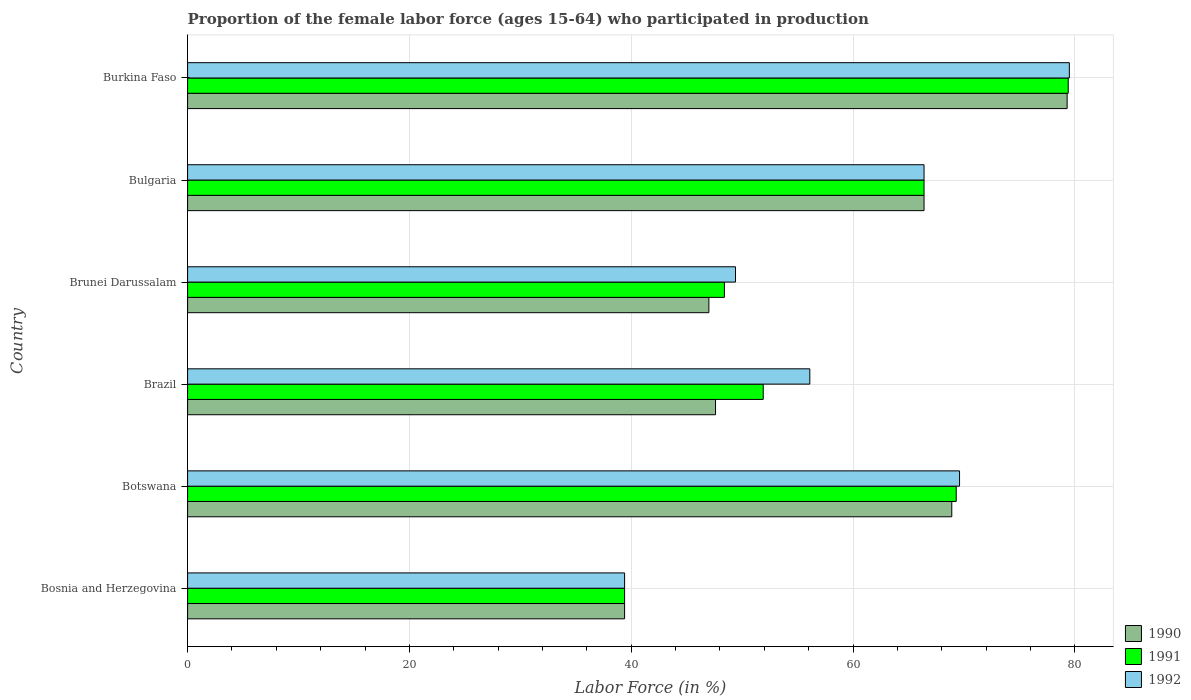How many different coloured bars are there?
Give a very brief answer. 3. How many groups of bars are there?
Keep it short and to the point. 6. Are the number of bars per tick equal to the number of legend labels?
Ensure brevity in your answer.  Yes. How many bars are there on the 2nd tick from the top?
Provide a short and direct response. 3. What is the label of the 4th group of bars from the top?
Give a very brief answer. Brazil. What is the proportion of the female labor force who participated in production in 1992 in Burkina Faso?
Offer a terse response. 79.5. Across all countries, what is the maximum proportion of the female labor force who participated in production in 1990?
Give a very brief answer. 79.3. Across all countries, what is the minimum proportion of the female labor force who participated in production in 1992?
Offer a terse response. 39.4. In which country was the proportion of the female labor force who participated in production in 1991 maximum?
Offer a very short reply. Burkina Faso. In which country was the proportion of the female labor force who participated in production in 1991 minimum?
Provide a short and direct response. Bosnia and Herzegovina. What is the total proportion of the female labor force who participated in production in 1990 in the graph?
Provide a short and direct response. 348.6. What is the difference between the proportion of the female labor force who participated in production in 1992 in Bulgaria and that in Burkina Faso?
Ensure brevity in your answer.  -13.1. What is the difference between the proportion of the female labor force who participated in production in 1990 in Brazil and the proportion of the female labor force who participated in production in 1992 in Bulgaria?
Provide a short and direct response. -18.8. What is the average proportion of the female labor force who participated in production in 1991 per country?
Make the answer very short. 59.13. What is the difference between the proportion of the female labor force who participated in production in 1990 and proportion of the female labor force who participated in production in 1991 in Burkina Faso?
Your response must be concise. -0.1. What is the ratio of the proportion of the female labor force who participated in production in 1990 in Botswana to that in Brunei Darussalam?
Provide a succinct answer. 1.47. Is the difference between the proportion of the female labor force who participated in production in 1990 in Bosnia and Herzegovina and Bulgaria greater than the difference between the proportion of the female labor force who participated in production in 1991 in Bosnia and Herzegovina and Bulgaria?
Provide a succinct answer. No. What is the difference between the highest and the second highest proportion of the female labor force who participated in production in 1990?
Give a very brief answer. 10.4. What is the difference between the highest and the lowest proportion of the female labor force who participated in production in 1991?
Provide a short and direct response. 40. Is the sum of the proportion of the female labor force who participated in production in 1992 in Bosnia and Herzegovina and Burkina Faso greater than the maximum proportion of the female labor force who participated in production in 1990 across all countries?
Your response must be concise. Yes. Is it the case that in every country, the sum of the proportion of the female labor force who participated in production in 1990 and proportion of the female labor force who participated in production in 1992 is greater than the proportion of the female labor force who participated in production in 1991?
Offer a terse response. Yes. Are all the bars in the graph horizontal?
Your answer should be compact. Yes. How many countries are there in the graph?
Your answer should be very brief. 6. Does the graph contain any zero values?
Provide a short and direct response. No. How many legend labels are there?
Your answer should be compact. 3. What is the title of the graph?
Keep it short and to the point. Proportion of the female labor force (ages 15-64) who participated in production. What is the label or title of the X-axis?
Give a very brief answer. Labor Force (in %). What is the label or title of the Y-axis?
Your response must be concise. Country. What is the Labor Force (in %) of 1990 in Bosnia and Herzegovina?
Give a very brief answer. 39.4. What is the Labor Force (in %) of 1991 in Bosnia and Herzegovina?
Ensure brevity in your answer.  39.4. What is the Labor Force (in %) in 1992 in Bosnia and Herzegovina?
Ensure brevity in your answer.  39.4. What is the Labor Force (in %) of 1990 in Botswana?
Give a very brief answer. 68.9. What is the Labor Force (in %) of 1991 in Botswana?
Your answer should be very brief. 69.3. What is the Labor Force (in %) of 1992 in Botswana?
Provide a succinct answer. 69.6. What is the Labor Force (in %) in 1990 in Brazil?
Your response must be concise. 47.6. What is the Labor Force (in %) in 1991 in Brazil?
Your answer should be compact. 51.9. What is the Labor Force (in %) of 1992 in Brazil?
Give a very brief answer. 56.1. What is the Labor Force (in %) of 1990 in Brunei Darussalam?
Make the answer very short. 47. What is the Labor Force (in %) in 1991 in Brunei Darussalam?
Offer a terse response. 48.4. What is the Labor Force (in %) in 1992 in Brunei Darussalam?
Your answer should be compact. 49.4. What is the Labor Force (in %) of 1990 in Bulgaria?
Offer a terse response. 66.4. What is the Labor Force (in %) of 1991 in Bulgaria?
Make the answer very short. 66.4. What is the Labor Force (in %) of 1992 in Bulgaria?
Your answer should be very brief. 66.4. What is the Labor Force (in %) of 1990 in Burkina Faso?
Your response must be concise. 79.3. What is the Labor Force (in %) in 1991 in Burkina Faso?
Your answer should be compact. 79.4. What is the Labor Force (in %) of 1992 in Burkina Faso?
Give a very brief answer. 79.5. Across all countries, what is the maximum Labor Force (in %) of 1990?
Your answer should be very brief. 79.3. Across all countries, what is the maximum Labor Force (in %) in 1991?
Give a very brief answer. 79.4. Across all countries, what is the maximum Labor Force (in %) of 1992?
Provide a succinct answer. 79.5. Across all countries, what is the minimum Labor Force (in %) in 1990?
Give a very brief answer. 39.4. Across all countries, what is the minimum Labor Force (in %) of 1991?
Keep it short and to the point. 39.4. Across all countries, what is the minimum Labor Force (in %) of 1992?
Ensure brevity in your answer.  39.4. What is the total Labor Force (in %) of 1990 in the graph?
Make the answer very short. 348.6. What is the total Labor Force (in %) in 1991 in the graph?
Keep it short and to the point. 354.8. What is the total Labor Force (in %) in 1992 in the graph?
Offer a very short reply. 360.4. What is the difference between the Labor Force (in %) of 1990 in Bosnia and Herzegovina and that in Botswana?
Provide a succinct answer. -29.5. What is the difference between the Labor Force (in %) in 1991 in Bosnia and Herzegovina and that in Botswana?
Provide a short and direct response. -29.9. What is the difference between the Labor Force (in %) in 1992 in Bosnia and Herzegovina and that in Botswana?
Give a very brief answer. -30.2. What is the difference between the Labor Force (in %) of 1992 in Bosnia and Herzegovina and that in Brazil?
Make the answer very short. -16.7. What is the difference between the Labor Force (in %) of 1992 in Bosnia and Herzegovina and that in Brunei Darussalam?
Offer a terse response. -10. What is the difference between the Labor Force (in %) in 1990 in Bosnia and Herzegovina and that in Bulgaria?
Ensure brevity in your answer.  -27. What is the difference between the Labor Force (in %) in 1991 in Bosnia and Herzegovina and that in Bulgaria?
Your answer should be compact. -27. What is the difference between the Labor Force (in %) of 1990 in Bosnia and Herzegovina and that in Burkina Faso?
Provide a succinct answer. -39.9. What is the difference between the Labor Force (in %) of 1992 in Bosnia and Herzegovina and that in Burkina Faso?
Keep it short and to the point. -40.1. What is the difference between the Labor Force (in %) of 1990 in Botswana and that in Brazil?
Make the answer very short. 21.3. What is the difference between the Labor Force (in %) of 1992 in Botswana and that in Brazil?
Make the answer very short. 13.5. What is the difference between the Labor Force (in %) of 1990 in Botswana and that in Brunei Darussalam?
Give a very brief answer. 21.9. What is the difference between the Labor Force (in %) in 1991 in Botswana and that in Brunei Darussalam?
Your response must be concise. 20.9. What is the difference between the Labor Force (in %) in 1992 in Botswana and that in Brunei Darussalam?
Offer a terse response. 20.2. What is the difference between the Labor Force (in %) in 1991 in Botswana and that in Burkina Faso?
Your answer should be compact. -10.1. What is the difference between the Labor Force (in %) of 1992 in Botswana and that in Burkina Faso?
Your answer should be very brief. -9.9. What is the difference between the Labor Force (in %) in 1990 in Brazil and that in Brunei Darussalam?
Provide a short and direct response. 0.6. What is the difference between the Labor Force (in %) of 1991 in Brazil and that in Brunei Darussalam?
Offer a terse response. 3.5. What is the difference between the Labor Force (in %) in 1992 in Brazil and that in Brunei Darussalam?
Your answer should be compact. 6.7. What is the difference between the Labor Force (in %) in 1990 in Brazil and that in Bulgaria?
Your answer should be compact. -18.8. What is the difference between the Labor Force (in %) of 1990 in Brazil and that in Burkina Faso?
Provide a succinct answer. -31.7. What is the difference between the Labor Force (in %) in 1991 in Brazil and that in Burkina Faso?
Make the answer very short. -27.5. What is the difference between the Labor Force (in %) in 1992 in Brazil and that in Burkina Faso?
Provide a succinct answer. -23.4. What is the difference between the Labor Force (in %) in 1990 in Brunei Darussalam and that in Bulgaria?
Your answer should be compact. -19.4. What is the difference between the Labor Force (in %) of 1990 in Brunei Darussalam and that in Burkina Faso?
Provide a succinct answer. -32.3. What is the difference between the Labor Force (in %) of 1991 in Brunei Darussalam and that in Burkina Faso?
Your answer should be compact. -31. What is the difference between the Labor Force (in %) of 1992 in Brunei Darussalam and that in Burkina Faso?
Provide a short and direct response. -30.1. What is the difference between the Labor Force (in %) in 1990 in Bulgaria and that in Burkina Faso?
Offer a very short reply. -12.9. What is the difference between the Labor Force (in %) in 1991 in Bulgaria and that in Burkina Faso?
Offer a terse response. -13. What is the difference between the Labor Force (in %) in 1990 in Bosnia and Herzegovina and the Labor Force (in %) in 1991 in Botswana?
Your answer should be very brief. -29.9. What is the difference between the Labor Force (in %) in 1990 in Bosnia and Herzegovina and the Labor Force (in %) in 1992 in Botswana?
Ensure brevity in your answer.  -30.2. What is the difference between the Labor Force (in %) of 1991 in Bosnia and Herzegovina and the Labor Force (in %) of 1992 in Botswana?
Keep it short and to the point. -30.2. What is the difference between the Labor Force (in %) of 1990 in Bosnia and Herzegovina and the Labor Force (in %) of 1992 in Brazil?
Provide a succinct answer. -16.7. What is the difference between the Labor Force (in %) in 1991 in Bosnia and Herzegovina and the Labor Force (in %) in 1992 in Brazil?
Your answer should be very brief. -16.7. What is the difference between the Labor Force (in %) in 1991 in Bosnia and Herzegovina and the Labor Force (in %) in 1992 in Brunei Darussalam?
Your answer should be compact. -10. What is the difference between the Labor Force (in %) in 1990 in Bosnia and Herzegovina and the Labor Force (in %) in 1991 in Burkina Faso?
Ensure brevity in your answer.  -40. What is the difference between the Labor Force (in %) in 1990 in Bosnia and Herzegovina and the Labor Force (in %) in 1992 in Burkina Faso?
Provide a succinct answer. -40.1. What is the difference between the Labor Force (in %) in 1991 in Bosnia and Herzegovina and the Labor Force (in %) in 1992 in Burkina Faso?
Provide a succinct answer. -40.1. What is the difference between the Labor Force (in %) of 1990 in Botswana and the Labor Force (in %) of 1991 in Brazil?
Offer a very short reply. 17. What is the difference between the Labor Force (in %) of 1991 in Botswana and the Labor Force (in %) of 1992 in Brazil?
Provide a short and direct response. 13.2. What is the difference between the Labor Force (in %) of 1990 in Botswana and the Labor Force (in %) of 1991 in Brunei Darussalam?
Ensure brevity in your answer.  20.5. What is the difference between the Labor Force (in %) of 1990 in Botswana and the Labor Force (in %) of 1991 in Burkina Faso?
Keep it short and to the point. -10.5. What is the difference between the Labor Force (in %) in 1990 in Botswana and the Labor Force (in %) in 1992 in Burkina Faso?
Offer a very short reply. -10.6. What is the difference between the Labor Force (in %) of 1991 in Botswana and the Labor Force (in %) of 1992 in Burkina Faso?
Offer a very short reply. -10.2. What is the difference between the Labor Force (in %) in 1990 in Brazil and the Labor Force (in %) in 1991 in Brunei Darussalam?
Ensure brevity in your answer.  -0.8. What is the difference between the Labor Force (in %) of 1990 in Brazil and the Labor Force (in %) of 1992 in Brunei Darussalam?
Provide a succinct answer. -1.8. What is the difference between the Labor Force (in %) of 1991 in Brazil and the Labor Force (in %) of 1992 in Brunei Darussalam?
Your response must be concise. 2.5. What is the difference between the Labor Force (in %) in 1990 in Brazil and the Labor Force (in %) in 1991 in Bulgaria?
Offer a very short reply. -18.8. What is the difference between the Labor Force (in %) of 1990 in Brazil and the Labor Force (in %) of 1992 in Bulgaria?
Give a very brief answer. -18.8. What is the difference between the Labor Force (in %) of 1991 in Brazil and the Labor Force (in %) of 1992 in Bulgaria?
Your response must be concise. -14.5. What is the difference between the Labor Force (in %) in 1990 in Brazil and the Labor Force (in %) in 1991 in Burkina Faso?
Your answer should be very brief. -31.8. What is the difference between the Labor Force (in %) of 1990 in Brazil and the Labor Force (in %) of 1992 in Burkina Faso?
Provide a succinct answer. -31.9. What is the difference between the Labor Force (in %) of 1991 in Brazil and the Labor Force (in %) of 1992 in Burkina Faso?
Keep it short and to the point. -27.6. What is the difference between the Labor Force (in %) in 1990 in Brunei Darussalam and the Labor Force (in %) in 1991 in Bulgaria?
Ensure brevity in your answer.  -19.4. What is the difference between the Labor Force (in %) in 1990 in Brunei Darussalam and the Labor Force (in %) in 1992 in Bulgaria?
Offer a very short reply. -19.4. What is the difference between the Labor Force (in %) of 1991 in Brunei Darussalam and the Labor Force (in %) of 1992 in Bulgaria?
Your answer should be very brief. -18. What is the difference between the Labor Force (in %) in 1990 in Brunei Darussalam and the Labor Force (in %) in 1991 in Burkina Faso?
Your response must be concise. -32.4. What is the difference between the Labor Force (in %) in 1990 in Brunei Darussalam and the Labor Force (in %) in 1992 in Burkina Faso?
Make the answer very short. -32.5. What is the difference between the Labor Force (in %) of 1991 in Brunei Darussalam and the Labor Force (in %) of 1992 in Burkina Faso?
Your response must be concise. -31.1. What is the difference between the Labor Force (in %) in 1990 in Bulgaria and the Labor Force (in %) in 1991 in Burkina Faso?
Give a very brief answer. -13. What is the average Labor Force (in %) in 1990 per country?
Offer a terse response. 58.1. What is the average Labor Force (in %) of 1991 per country?
Your answer should be compact. 59.13. What is the average Labor Force (in %) in 1992 per country?
Your answer should be compact. 60.07. What is the difference between the Labor Force (in %) in 1990 and Labor Force (in %) in 1991 in Bosnia and Herzegovina?
Provide a succinct answer. 0. What is the difference between the Labor Force (in %) of 1990 and Labor Force (in %) of 1992 in Bosnia and Herzegovina?
Ensure brevity in your answer.  0. What is the difference between the Labor Force (in %) in 1991 and Labor Force (in %) in 1992 in Bosnia and Herzegovina?
Give a very brief answer. 0. What is the difference between the Labor Force (in %) of 1990 and Labor Force (in %) of 1991 in Brazil?
Ensure brevity in your answer.  -4.3. What is the difference between the Labor Force (in %) in 1990 and Labor Force (in %) in 1992 in Brazil?
Keep it short and to the point. -8.5. What is the difference between the Labor Force (in %) of 1990 and Labor Force (in %) of 1991 in Brunei Darussalam?
Provide a short and direct response. -1.4. What is the difference between the Labor Force (in %) of 1990 and Labor Force (in %) of 1992 in Bulgaria?
Make the answer very short. 0. What is the difference between the Labor Force (in %) in 1990 and Labor Force (in %) in 1991 in Burkina Faso?
Provide a succinct answer. -0.1. What is the difference between the Labor Force (in %) of 1991 and Labor Force (in %) of 1992 in Burkina Faso?
Make the answer very short. -0.1. What is the ratio of the Labor Force (in %) in 1990 in Bosnia and Herzegovina to that in Botswana?
Provide a succinct answer. 0.57. What is the ratio of the Labor Force (in %) of 1991 in Bosnia and Herzegovina to that in Botswana?
Offer a terse response. 0.57. What is the ratio of the Labor Force (in %) of 1992 in Bosnia and Herzegovina to that in Botswana?
Provide a succinct answer. 0.57. What is the ratio of the Labor Force (in %) of 1990 in Bosnia and Herzegovina to that in Brazil?
Provide a short and direct response. 0.83. What is the ratio of the Labor Force (in %) in 1991 in Bosnia and Herzegovina to that in Brazil?
Your response must be concise. 0.76. What is the ratio of the Labor Force (in %) of 1992 in Bosnia and Herzegovina to that in Brazil?
Your answer should be compact. 0.7. What is the ratio of the Labor Force (in %) of 1990 in Bosnia and Herzegovina to that in Brunei Darussalam?
Your answer should be very brief. 0.84. What is the ratio of the Labor Force (in %) of 1991 in Bosnia and Herzegovina to that in Brunei Darussalam?
Give a very brief answer. 0.81. What is the ratio of the Labor Force (in %) in 1992 in Bosnia and Herzegovina to that in Brunei Darussalam?
Offer a terse response. 0.8. What is the ratio of the Labor Force (in %) of 1990 in Bosnia and Herzegovina to that in Bulgaria?
Offer a terse response. 0.59. What is the ratio of the Labor Force (in %) in 1991 in Bosnia and Herzegovina to that in Bulgaria?
Give a very brief answer. 0.59. What is the ratio of the Labor Force (in %) in 1992 in Bosnia and Herzegovina to that in Bulgaria?
Your response must be concise. 0.59. What is the ratio of the Labor Force (in %) of 1990 in Bosnia and Herzegovina to that in Burkina Faso?
Your answer should be compact. 0.5. What is the ratio of the Labor Force (in %) of 1991 in Bosnia and Herzegovina to that in Burkina Faso?
Offer a terse response. 0.5. What is the ratio of the Labor Force (in %) of 1992 in Bosnia and Herzegovina to that in Burkina Faso?
Provide a succinct answer. 0.5. What is the ratio of the Labor Force (in %) of 1990 in Botswana to that in Brazil?
Give a very brief answer. 1.45. What is the ratio of the Labor Force (in %) of 1991 in Botswana to that in Brazil?
Provide a short and direct response. 1.34. What is the ratio of the Labor Force (in %) in 1992 in Botswana to that in Brazil?
Offer a terse response. 1.24. What is the ratio of the Labor Force (in %) in 1990 in Botswana to that in Brunei Darussalam?
Offer a terse response. 1.47. What is the ratio of the Labor Force (in %) in 1991 in Botswana to that in Brunei Darussalam?
Your answer should be very brief. 1.43. What is the ratio of the Labor Force (in %) in 1992 in Botswana to that in Brunei Darussalam?
Ensure brevity in your answer.  1.41. What is the ratio of the Labor Force (in %) in 1990 in Botswana to that in Bulgaria?
Offer a terse response. 1.04. What is the ratio of the Labor Force (in %) in 1991 in Botswana to that in Bulgaria?
Ensure brevity in your answer.  1.04. What is the ratio of the Labor Force (in %) of 1992 in Botswana to that in Bulgaria?
Offer a very short reply. 1.05. What is the ratio of the Labor Force (in %) of 1990 in Botswana to that in Burkina Faso?
Keep it short and to the point. 0.87. What is the ratio of the Labor Force (in %) of 1991 in Botswana to that in Burkina Faso?
Keep it short and to the point. 0.87. What is the ratio of the Labor Force (in %) in 1992 in Botswana to that in Burkina Faso?
Ensure brevity in your answer.  0.88. What is the ratio of the Labor Force (in %) of 1990 in Brazil to that in Brunei Darussalam?
Your response must be concise. 1.01. What is the ratio of the Labor Force (in %) in 1991 in Brazil to that in Brunei Darussalam?
Your response must be concise. 1.07. What is the ratio of the Labor Force (in %) in 1992 in Brazil to that in Brunei Darussalam?
Make the answer very short. 1.14. What is the ratio of the Labor Force (in %) of 1990 in Brazil to that in Bulgaria?
Offer a very short reply. 0.72. What is the ratio of the Labor Force (in %) of 1991 in Brazil to that in Bulgaria?
Ensure brevity in your answer.  0.78. What is the ratio of the Labor Force (in %) of 1992 in Brazil to that in Bulgaria?
Provide a succinct answer. 0.84. What is the ratio of the Labor Force (in %) in 1990 in Brazil to that in Burkina Faso?
Your answer should be compact. 0.6. What is the ratio of the Labor Force (in %) of 1991 in Brazil to that in Burkina Faso?
Your response must be concise. 0.65. What is the ratio of the Labor Force (in %) in 1992 in Brazil to that in Burkina Faso?
Give a very brief answer. 0.71. What is the ratio of the Labor Force (in %) of 1990 in Brunei Darussalam to that in Bulgaria?
Provide a short and direct response. 0.71. What is the ratio of the Labor Force (in %) of 1991 in Brunei Darussalam to that in Bulgaria?
Your answer should be compact. 0.73. What is the ratio of the Labor Force (in %) of 1992 in Brunei Darussalam to that in Bulgaria?
Offer a very short reply. 0.74. What is the ratio of the Labor Force (in %) of 1990 in Brunei Darussalam to that in Burkina Faso?
Your response must be concise. 0.59. What is the ratio of the Labor Force (in %) in 1991 in Brunei Darussalam to that in Burkina Faso?
Your response must be concise. 0.61. What is the ratio of the Labor Force (in %) of 1992 in Brunei Darussalam to that in Burkina Faso?
Offer a terse response. 0.62. What is the ratio of the Labor Force (in %) in 1990 in Bulgaria to that in Burkina Faso?
Your response must be concise. 0.84. What is the ratio of the Labor Force (in %) of 1991 in Bulgaria to that in Burkina Faso?
Give a very brief answer. 0.84. What is the ratio of the Labor Force (in %) of 1992 in Bulgaria to that in Burkina Faso?
Your response must be concise. 0.84. What is the difference between the highest and the second highest Labor Force (in %) in 1991?
Make the answer very short. 10.1. What is the difference between the highest and the second highest Labor Force (in %) of 1992?
Your answer should be very brief. 9.9. What is the difference between the highest and the lowest Labor Force (in %) in 1990?
Keep it short and to the point. 39.9. What is the difference between the highest and the lowest Labor Force (in %) in 1991?
Provide a succinct answer. 40. What is the difference between the highest and the lowest Labor Force (in %) in 1992?
Ensure brevity in your answer.  40.1. 